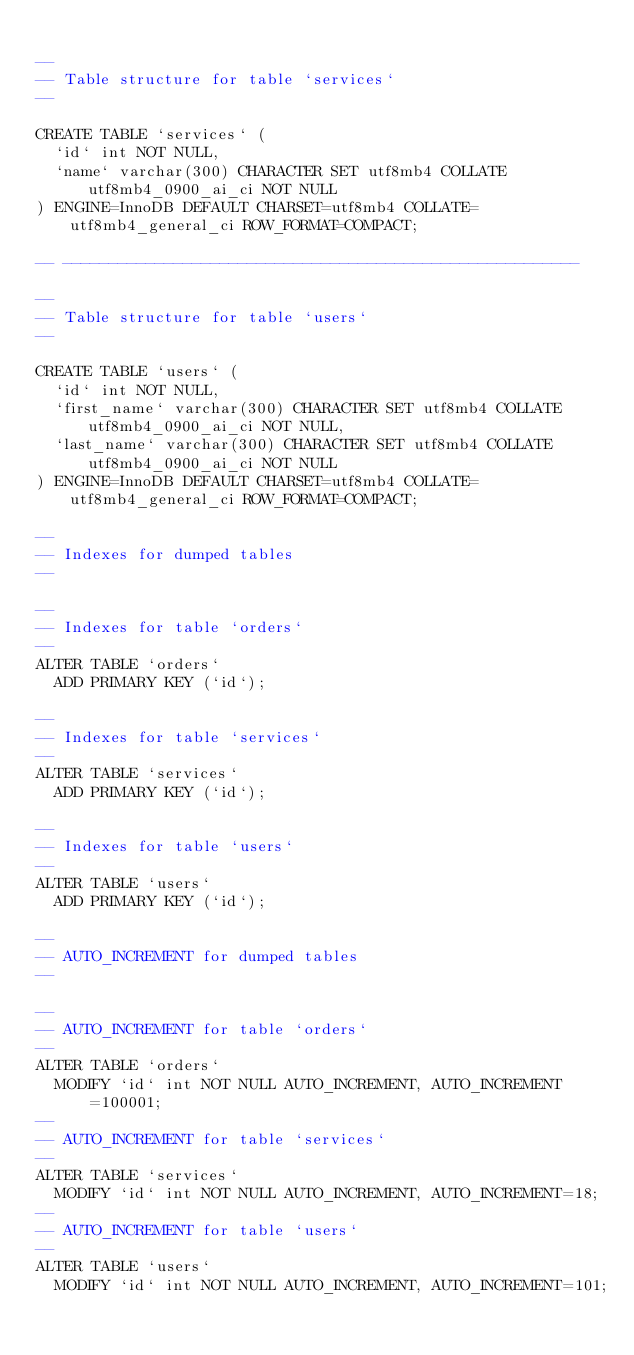<code> <loc_0><loc_0><loc_500><loc_500><_SQL_>
--
-- Table structure for table `services`
--

CREATE TABLE `services` (
  `id` int NOT NULL,
  `name` varchar(300) CHARACTER SET utf8mb4 COLLATE utf8mb4_0900_ai_ci NOT NULL
) ENGINE=InnoDB DEFAULT CHARSET=utf8mb4 COLLATE=utf8mb4_general_ci ROW_FORMAT=COMPACT;

-- --------------------------------------------------------

--
-- Table structure for table `users`
--

CREATE TABLE `users` (
  `id` int NOT NULL,
  `first_name` varchar(300) CHARACTER SET utf8mb4 COLLATE utf8mb4_0900_ai_ci NOT NULL,
  `last_name` varchar(300) CHARACTER SET utf8mb4 COLLATE utf8mb4_0900_ai_ci NOT NULL
) ENGINE=InnoDB DEFAULT CHARSET=utf8mb4 COLLATE=utf8mb4_general_ci ROW_FORMAT=COMPACT;

--
-- Indexes for dumped tables
--

--
-- Indexes for table `orders`
--
ALTER TABLE `orders`
  ADD PRIMARY KEY (`id`);

--
-- Indexes for table `services`
--
ALTER TABLE `services`
  ADD PRIMARY KEY (`id`);

--
-- Indexes for table `users`
--
ALTER TABLE `users`
  ADD PRIMARY KEY (`id`);

--
-- AUTO_INCREMENT for dumped tables
--

--
-- AUTO_INCREMENT for table `orders`
--
ALTER TABLE `orders`
  MODIFY `id` int NOT NULL AUTO_INCREMENT, AUTO_INCREMENT=100001;
--
-- AUTO_INCREMENT for table `services`
--
ALTER TABLE `services`
  MODIFY `id` int NOT NULL AUTO_INCREMENT, AUTO_INCREMENT=18;
--
-- AUTO_INCREMENT for table `users`
--
ALTER TABLE `users`
  MODIFY `id` int NOT NULL AUTO_INCREMENT, AUTO_INCREMENT=101;</code> 